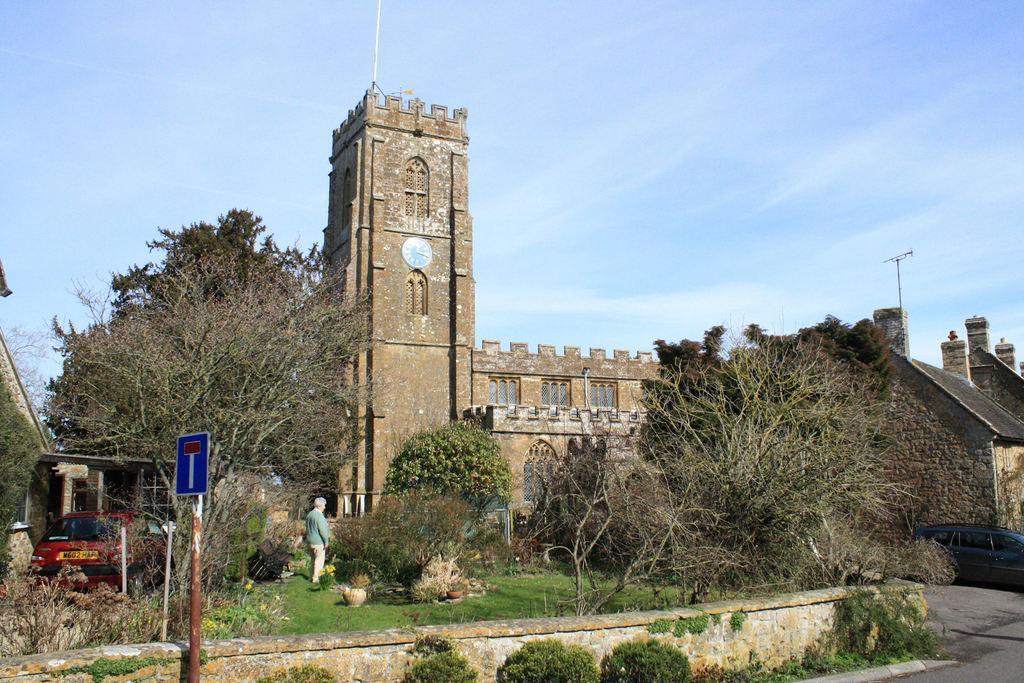Can you describe this image briefly? We can see board on pole and we can see plants,grass and cars. There is a person standing. Background we can see building and we can see clock on this building. We can see sky with clouds. 